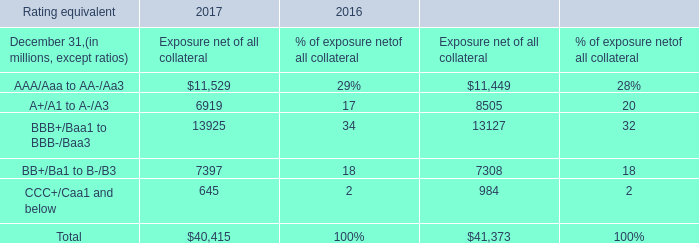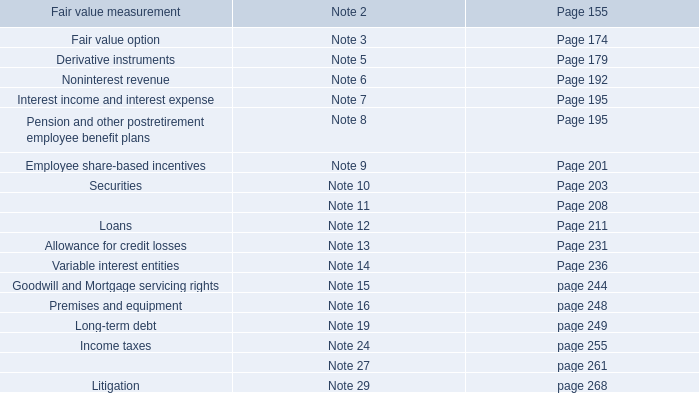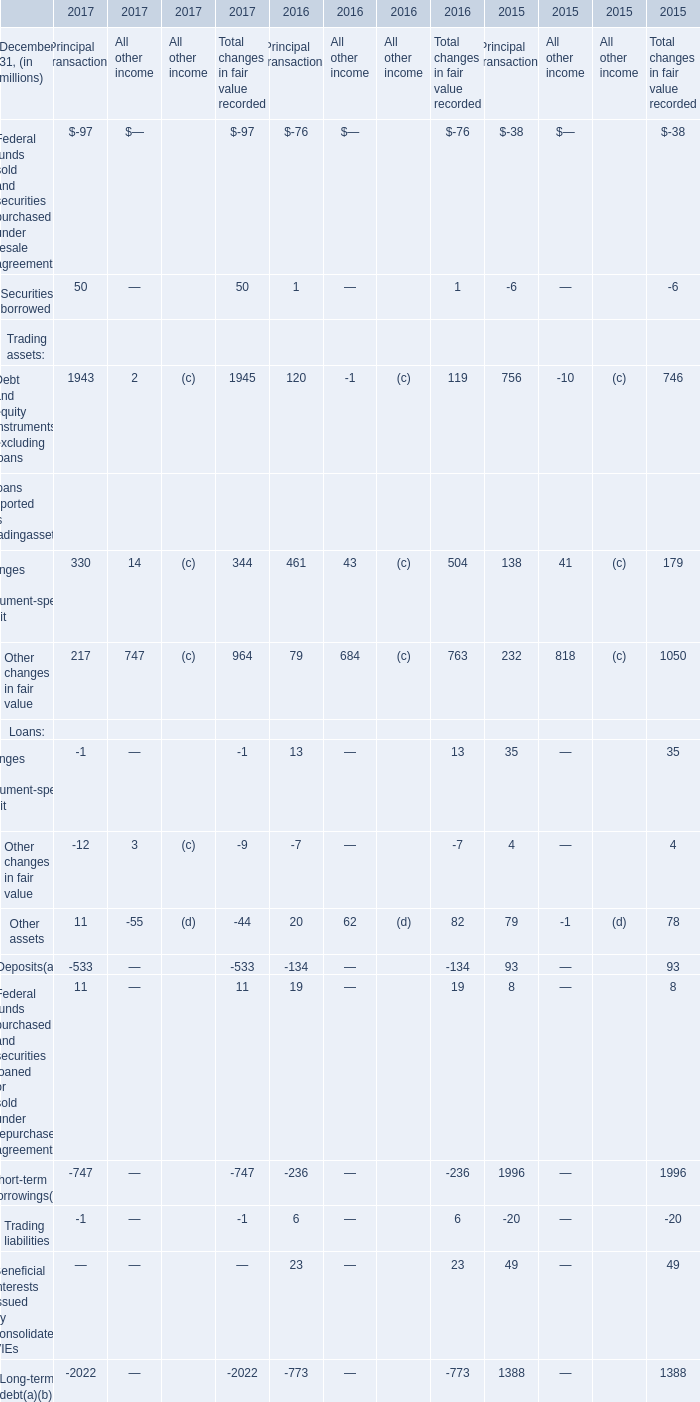What was the sum of the Securities borrowed for Principal transactions that is greater than 40 million? (in million) 
Answer: 50. 